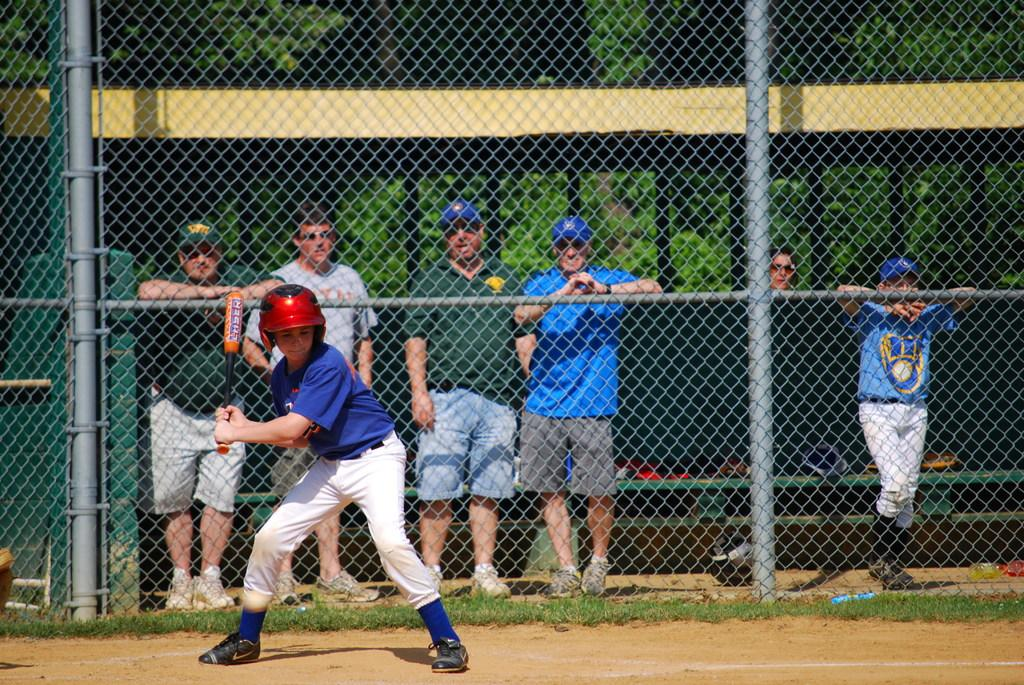What is the person holding in the image? The person is holding a baseball stick in the image. What are the other people in the image doing? They are holding a metal fence in the image. What can be seen in the background of the image? There are trees in the background of the image. What type of grape is being used as a protest symbol in the image? There is no grape or protest symbol present in the image; it features a person holding a baseball stick and other people holding a metal fence. 